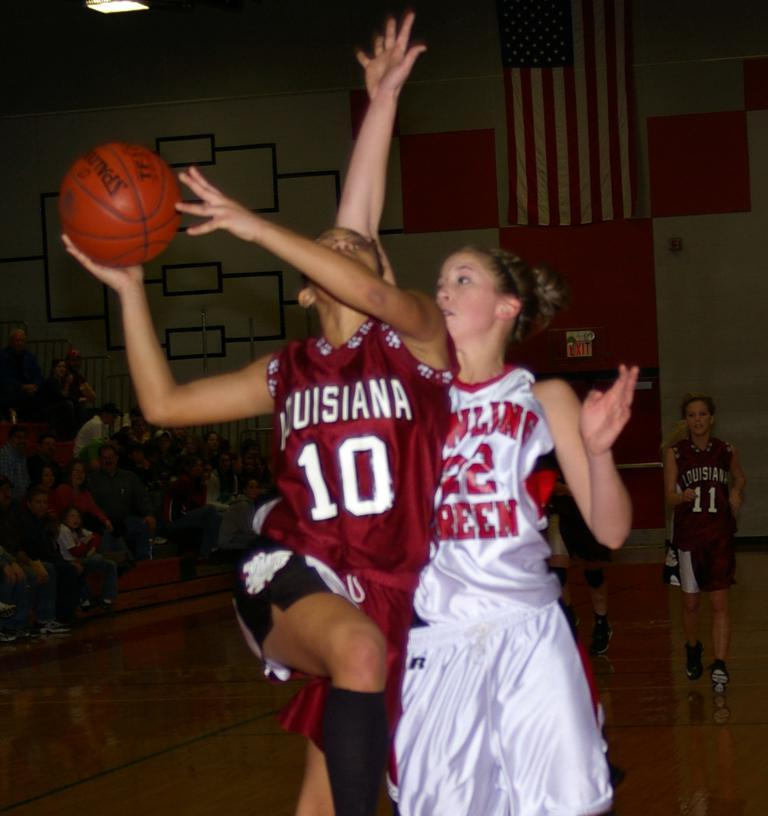Provide a one-sentence caption for the provided image. Two female basketball player from opposing teams as number 10 Louisianna jumps to make a shot. 